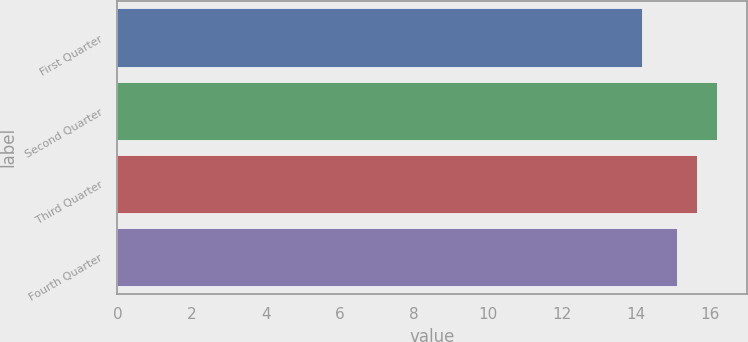Convert chart to OTSL. <chart><loc_0><loc_0><loc_500><loc_500><bar_chart><fcel>First Quarter<fcel>Second Quarter<fcel>Third Quarter<fcel>Fourth Quarter<nl><fcel>14.14<fcel>16.19<fcel>15.65<fcel>15.1<nl></chart> 